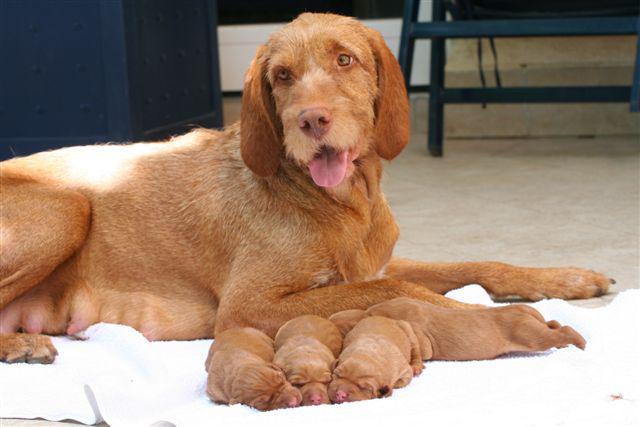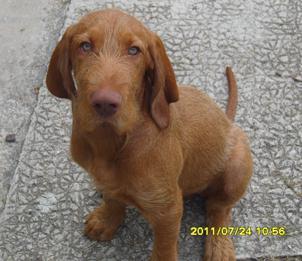The first image is the image on the left, the second image is the image on the right. Analyze the images presented: Is the assertion "The right image features one dog in a sitting pose with body turned left and head turned straight, and the left image features a reclining mother dog with at least four puppies in front of her." valid? Answer yes or no. Yes. 